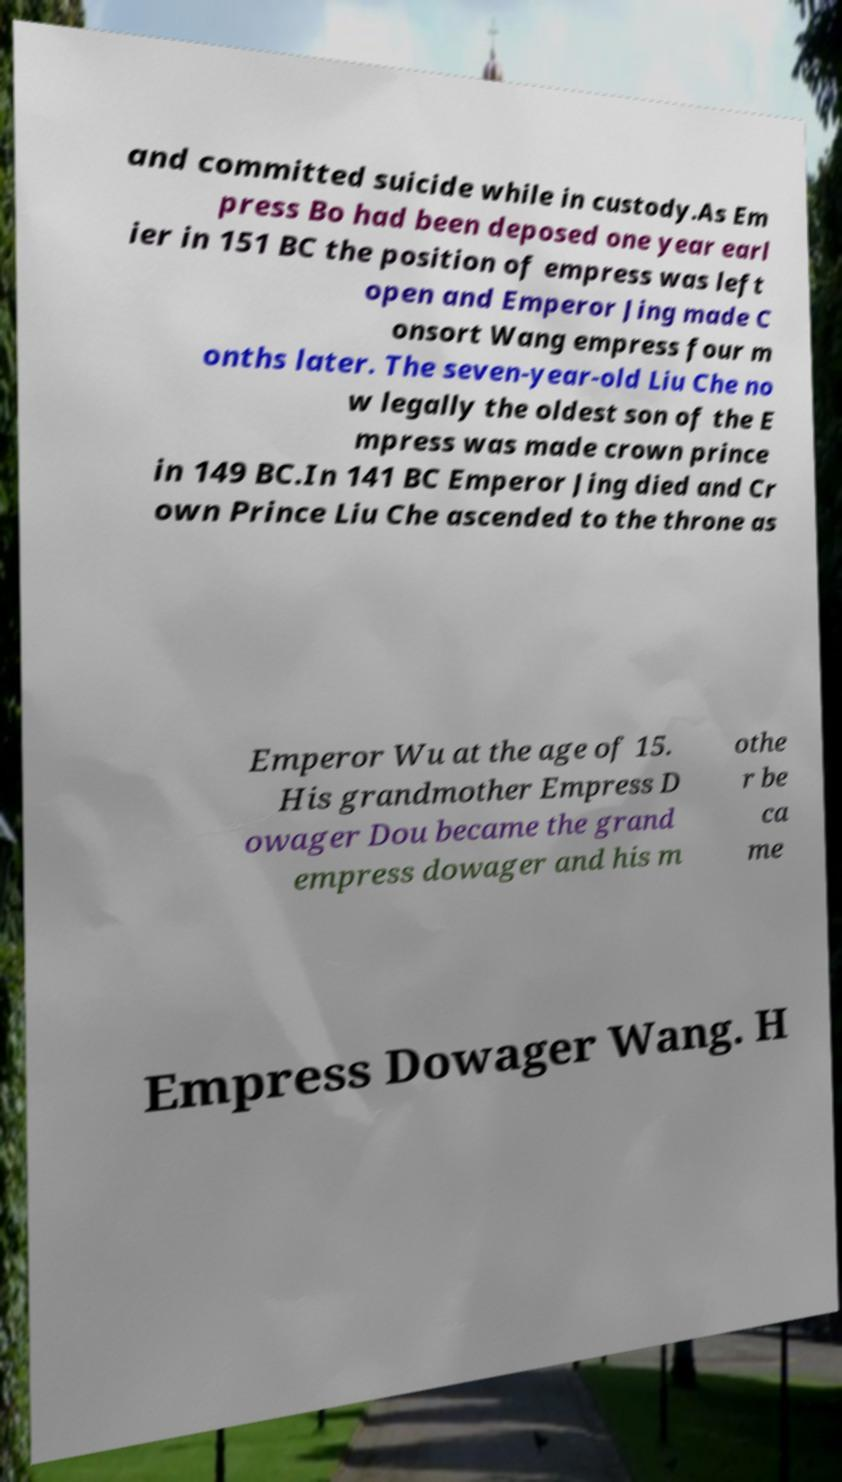Can you read and provide the text displayed in the image?This photo seems to have some interesting text. Can you extract and type it out for me? and committed suicide while in custody.As Em press Bo had been deposed one year earl ier in 151 BC the position of empress was left open and Emperor Jing made C onsort Wang empress four m onths later. The seven-year-old Liu Che no w legally the oldest son of the E mpress was made crown prince in 149 BC.In 141 BC Emperor Jing died and Cr own Prince Liu Che ascended to the throne as Emperor Wu at the age of 15. His grandmother Empress D owager Dou became the grand empress dowager and his m othe r be ca me Empress Dowager Wang. H 